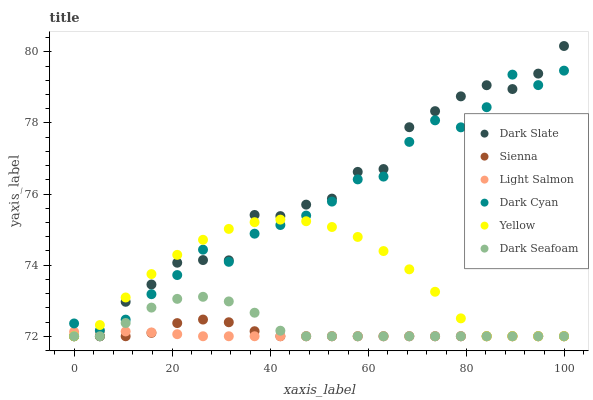Does Light Salmon have the minimum area under the curve?
Answer yes or no. Yes. Does Dark Slate have the maximum area under the curve?
Answer yes or no. Yes. Does Yellow have the minimum area under the curve?
Answer yes or no. No. Does Yellow have the maximum area under the curve?
Answer yes or no. No. Is Light Salmon the smoothest?
Answer yes or no. Yes. Is Dark Cyan the roughest?
Answer yes or no. Yes. Is Yellow the smoothest?
Answer yes or no. No. Is Yellow the roughest?
Answer yes or no. No. Does Light Salmon have the lowest value?
Answer yes or no. Yes. Does Dark Cyan have the lowest value?
Answer yes or no. No. Does Dark Slate have the highest value?
Answer yes or no. Yes. Does Yellow have the highest value?
Answer yes or no. No. Is Sienna less than Dark Cyan?
Answer yes or no. Yes. Is Dark Cyan greater than Dark Seafoam?
Answer yes or no. Yes. Does Dark Seafoam intersect Dark Slate?
Answer yes or no. Yes. Is Dark Seafoam less than Dark Slate?
Answer yes or no. No. Is Dark Seafoam greater than Dark Slate?
Answer yes or no. No. Does Sienna intersect Dark Cyan?
Answer yes or no. No. 